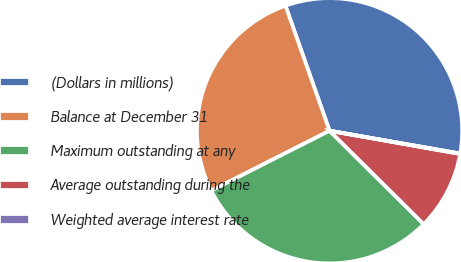Convert chart to OTSL. <chart><loc_0><loc_0><loc_500><loc_500><pie_chart><fcel>(Dollars in millions)<fcel>Balance at December 31<fcel>Maximum outstanding at any<fcel>Average outstanding during the<fcel>Weighted average interest rate<nl><fcel>33.14%<fcel>27.07%<fcel>30.1%<fcel>9.64%<fcel>0.05%<nl></chart> 